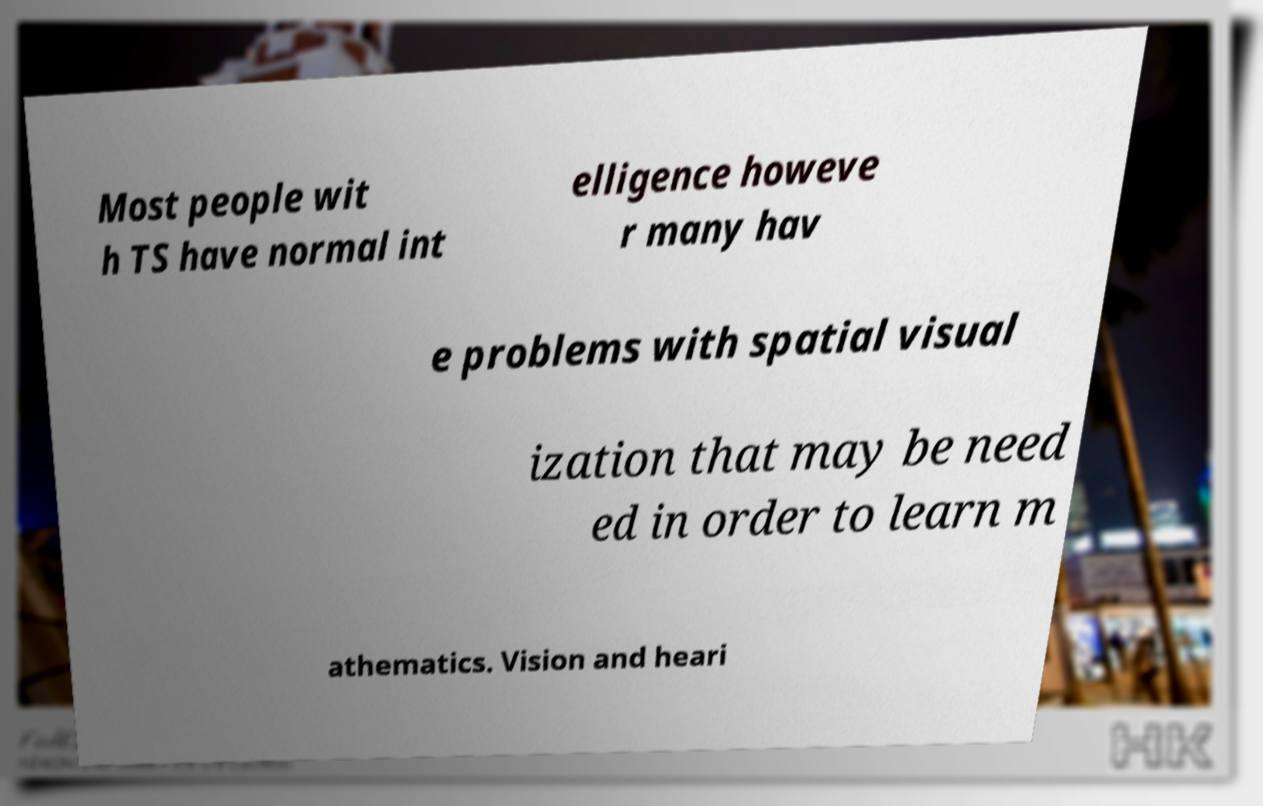For documentation purposes, I need the text within this image transcribed. Could you provide that? Most people wit h TS have normal int elligence howeve r many hav e problems with spatial visual ization that may be need ed in order to learn m athematics. Vision and heari 